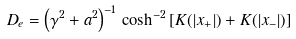Convert formula to latex. <formula><loc_0><loc_0><loc_500><loc_500>D _ { e } = \left ( \gamma ^ { 2 } + a ^ { 2 } \right ) ^ { - 1 } \, \cosh ^ { - 2 } \left [ K ( | x _ { + } | ) + K ( | x _ { - } | ) \right ]</formula> 